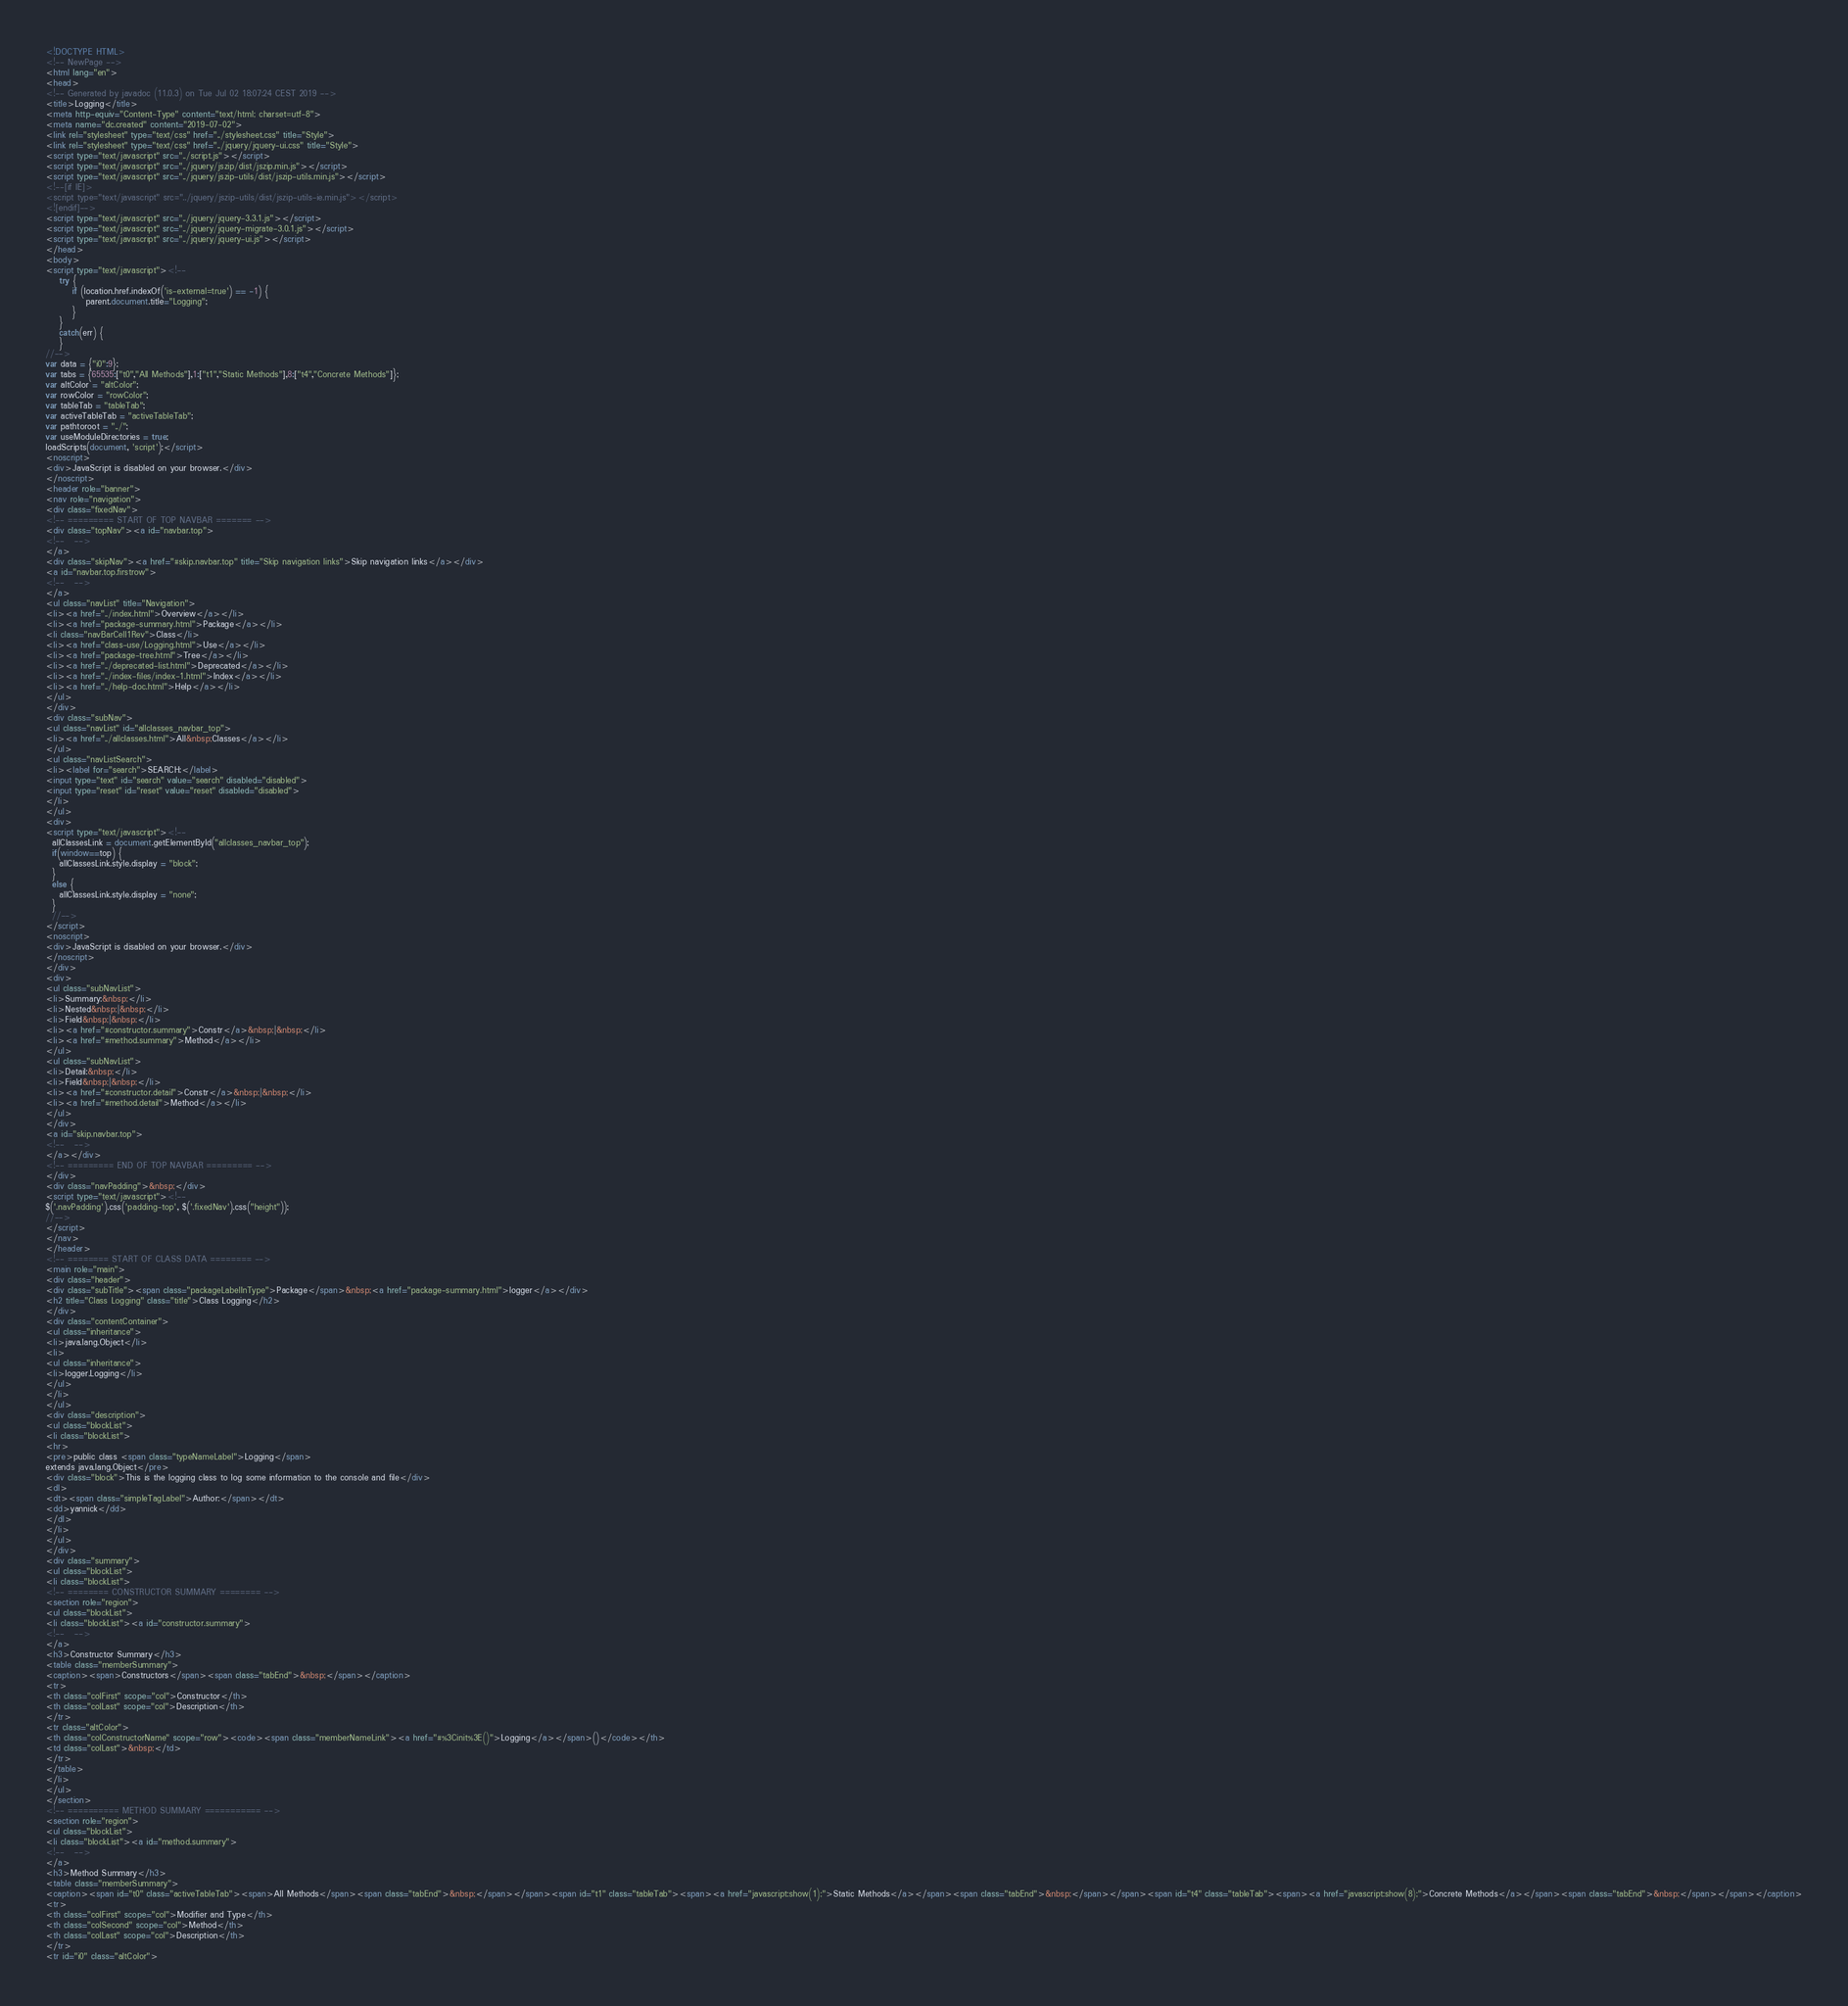<code> <loc_0><loc_0><loc_500><loc_500><_HTML_><!DOCTYPE HTML>
<!-- NewPage -->
<html lang="en">
<head>
<!-- Generated by javadoc (11.0.3) on Tue Jul 02 18:07:24 CEST 2019 -->
<title>Logging</title>
<meta http-equiv="Content-Type" content="text/html; charset=utf-8">
<meta name="dc.created" content="2019-07-02">
<link rel="stylesheet" type="text/css" href="../stylesheet.css" title="Style">
<link rel="stylesheet" type="text/css" href="../jquery/jquery-ui.css" title="Style">
<script type="text/javascript" src="../script.js"></script>
<script type="text/javascript" src="../jquery/jszip/dist/jszip.min.js"></script>
<script type="text/javascript" src="../jquery/jszip-utils/dist/jszip-utils.min.js"></script>
<!--[if IE]>
<script type="text/javascript" src="../jquery/jszip-utils/dist/jszip-utils-ie.min.js"></script>
<![endif]-->
<script type="text/javascript" src="../jquery/jquery-3.3.1.js"></script>
<script type="text/javascript" src="../jquery/jquery-migrate-3.0.1.js"></script>
<script type="text/javascript" src="../jquery/jquery-ui.js"></script>
</head>
<body>
<script type="text/javascript"><!--
    try {
        if (location.href.indexOf('is-external=true') == -1) {
            parent.document.title="Logging";
        }
    }
    catch(err) {
    }
//-->
var data = {"i0":9};
var tabs = {65535:["t0","All Methods"],1:["t1","Static Methods"],8:["t4","Concrete Methods"]};
var altColor = "altColor";
var rowColor = "rowColor";
var tableTab = "tableTab";
var activeTableTab = "activeTableTab";
var pathtoroot = "../";
var useModuleDirectories = true;
loadScripts(document, 'script');</script>
<noscript>
<div>JavaScript is disabled on your browser.</div>
</noscript>
<header role="banner">
<nav role="navigation">
<div class="fixedNav">
<!-- ========= START OF TOP NAVBAR ======= -->
<div class="topNav"><a id="navbar.top">
<!--   -->
</a>
<div class="skipNav"><a href="#skip.navbar.top" title="Skip navigation links">Skip navigation links</a></div>
<a id="navbar.top.firstrow">
<!--   -->
</a>
<ul class="navList" title="Navigation">
<li><a href="../index.html">Overview</a></li>
<li><a href="package-summary.html">Package</a></li>
<li class="navBarCell1Rev">Class</li>
<li><a href="class-use/Logging.html">Use</a></li>
<li><a href="package-tree.html">Tree</a></li>
<li><a href="../deprecated-list.html">Deprecated</a></li>
<li><a href="../index-files/index-1.html">Index</a></li>
<li><a href="../help-doc.html">Help</a></li>
</ul>
</div>
<div class="subNav">
<ul class="navList" id="allclasses_navbar_top">
<li><a href="../allclasses.html">All&nbsp;Classes</a></li>
</ul>
<ul class="navListSearch">
<li><label for="search">SEARCH:</label>
<input type="text" id="search" value="search" disabled="disabled">
<input type="reset" id="reset" value="reset" disabled="disabled">
</li>
</ul>
<div>
<script type="text/javascript"><!--
  allClassesLink = document.getElementById("allclasses_navbar_top");
  if(window==top) {
    allClassesLink.style.display = "block";
  }
  else {
    allClassesLink.style.display = "none";
  }
  //-->
</script>
<noscript>
<div>JavaScript is disabled on your browser.</div>
</noscript>
</div>
<div>
<ul class="subNavList">
<li>Summary:&nbsp;</li>
<li>Nested&nbsp;|&nbsp;</li>
<li>Field&nbsp;|&nbsp;</li>
<li><a href="#constructor.summary">Constr</a>&nbsp;|&nbsp;</li>
<li><a href="#method.summary">Method</a></li>
</ul>
<ul class="subNavList">
<li>Detail:&nbsp;</li>
<li>Field&nbsp;|&nbsp;</li>
<li><a href="#constructor.detail">Constr</a>&nbsp;|&nbsp;</li>
<li><a href="#method.detail">Method</a></li>
</ul>
</div>
<a id="skip.navbar.top">
<!--   -->
</a></div>
<!-- ========= END OF TOP NAVBAR ========= -->
</div>
<div class="navPadding">&nbsp;</div>
<script type="text/javascript"><!--
$('.navPadding').css('padding-top', $('.fixedNav').css("height"));
//-->
</script>
</nav>
</header>
<!-- ======== START OF CLASS DATA ======== -->
<main role="main">
<div class="header">
<div class="subTitle"><span class="packageLabelInType">Package</span>&nbsp;<a href="package-summary.html">logger</a></div>
<h2 title="Class Logging" class="title">Class Logging</h2>
</div>
<div class="contentContainer">
<ul class="inheritance">
<li>java.lang.Object</li>
<li>
<ul class="inheritance">
<li>logger.Logging</li>
</ul>
</li>
</ul>
<div class="description">
<ul class="blockList">
<li class="blockList">
<hr>
<pre>public class <span class="typeNameLabel">Logging</span>
extends java.lang.Object</pre>
<div class="block">This is the logging class to log some information to the console and file</div>
<dl>
<dt><span class="simpleTagLabel">Author:</span></dt>
<dd>yannick</dd>
</dl>
</li>
</ul>
</div>
<div class="summary">
<ul class="blockList">
<li class="blockList">
<!-- ======== CONSTRUCTOR SUMMARY ======== -->
<section role="region">
<ul class="blockList">
<li class="blockList"><a id="constructor.summary">
<!--   -->
</a>
<h3>Constructor Summary</h3>
<table class="memberSummary">
<caption><span>Constructors</span><span class="tabEnd">&nbsp;</span></caption>
<tr>
<th class="colFirst" scope="col">Constructor</th>
<th class="colLast" scope="col">Description</th>
</tr>
<tr class="altColor">
<th class="colConstructorName" scope="row"><code><span class="memberNameLink"><a href="#%3Cinit%3E()">Logging</a></span>()</code></th>
<td class="colLast">&nbsp;</td>
</tr>
</table>
</li>
</ul>
</section>
<!-- ========== METHOD SUMMARY =========== -->
<section role="region">
<ul class="blockList">
<li class="blockList"><a id="method.summary">
<!--   -->
</a>
<h3>Method Summary</h3>
<table class="memberSummary">
<caption><span id="t0" class="activeTableTab"><span>All Methods</span><span class="tabEnd">&nbsp;</span></span><span id="t1" class="tableTab"><span><a href="javascript:show(1);">Static Methods</a></span><span class="tabEnd">&nbsp;</span></span><span id="t4" class="tableTab"><span><a href="javascript:show(8);">Concrete Methods</a></span><span class="tabEnd">&nbsp;</span></span></caption>
<tr>
<th class="colFirst" scope="col">Modifier and Type</th>
<th class="colSecond" scope="col">Method</th>
<th class="colLast" scope="col">Description</th>
</tr>
<tr id="i0" class="altColor"></code> 